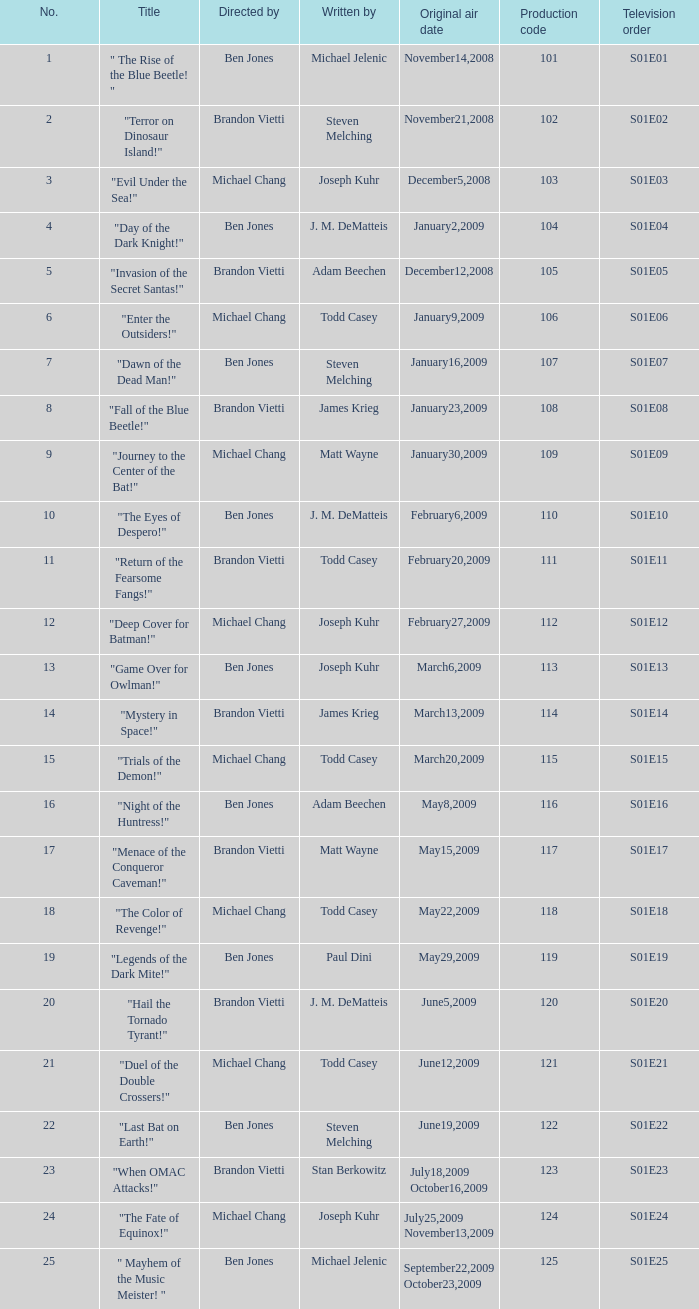What is the television order of the episode directed by ben jones, written by j. m. dematteis and originally aired on february6,2009 S01E10. 